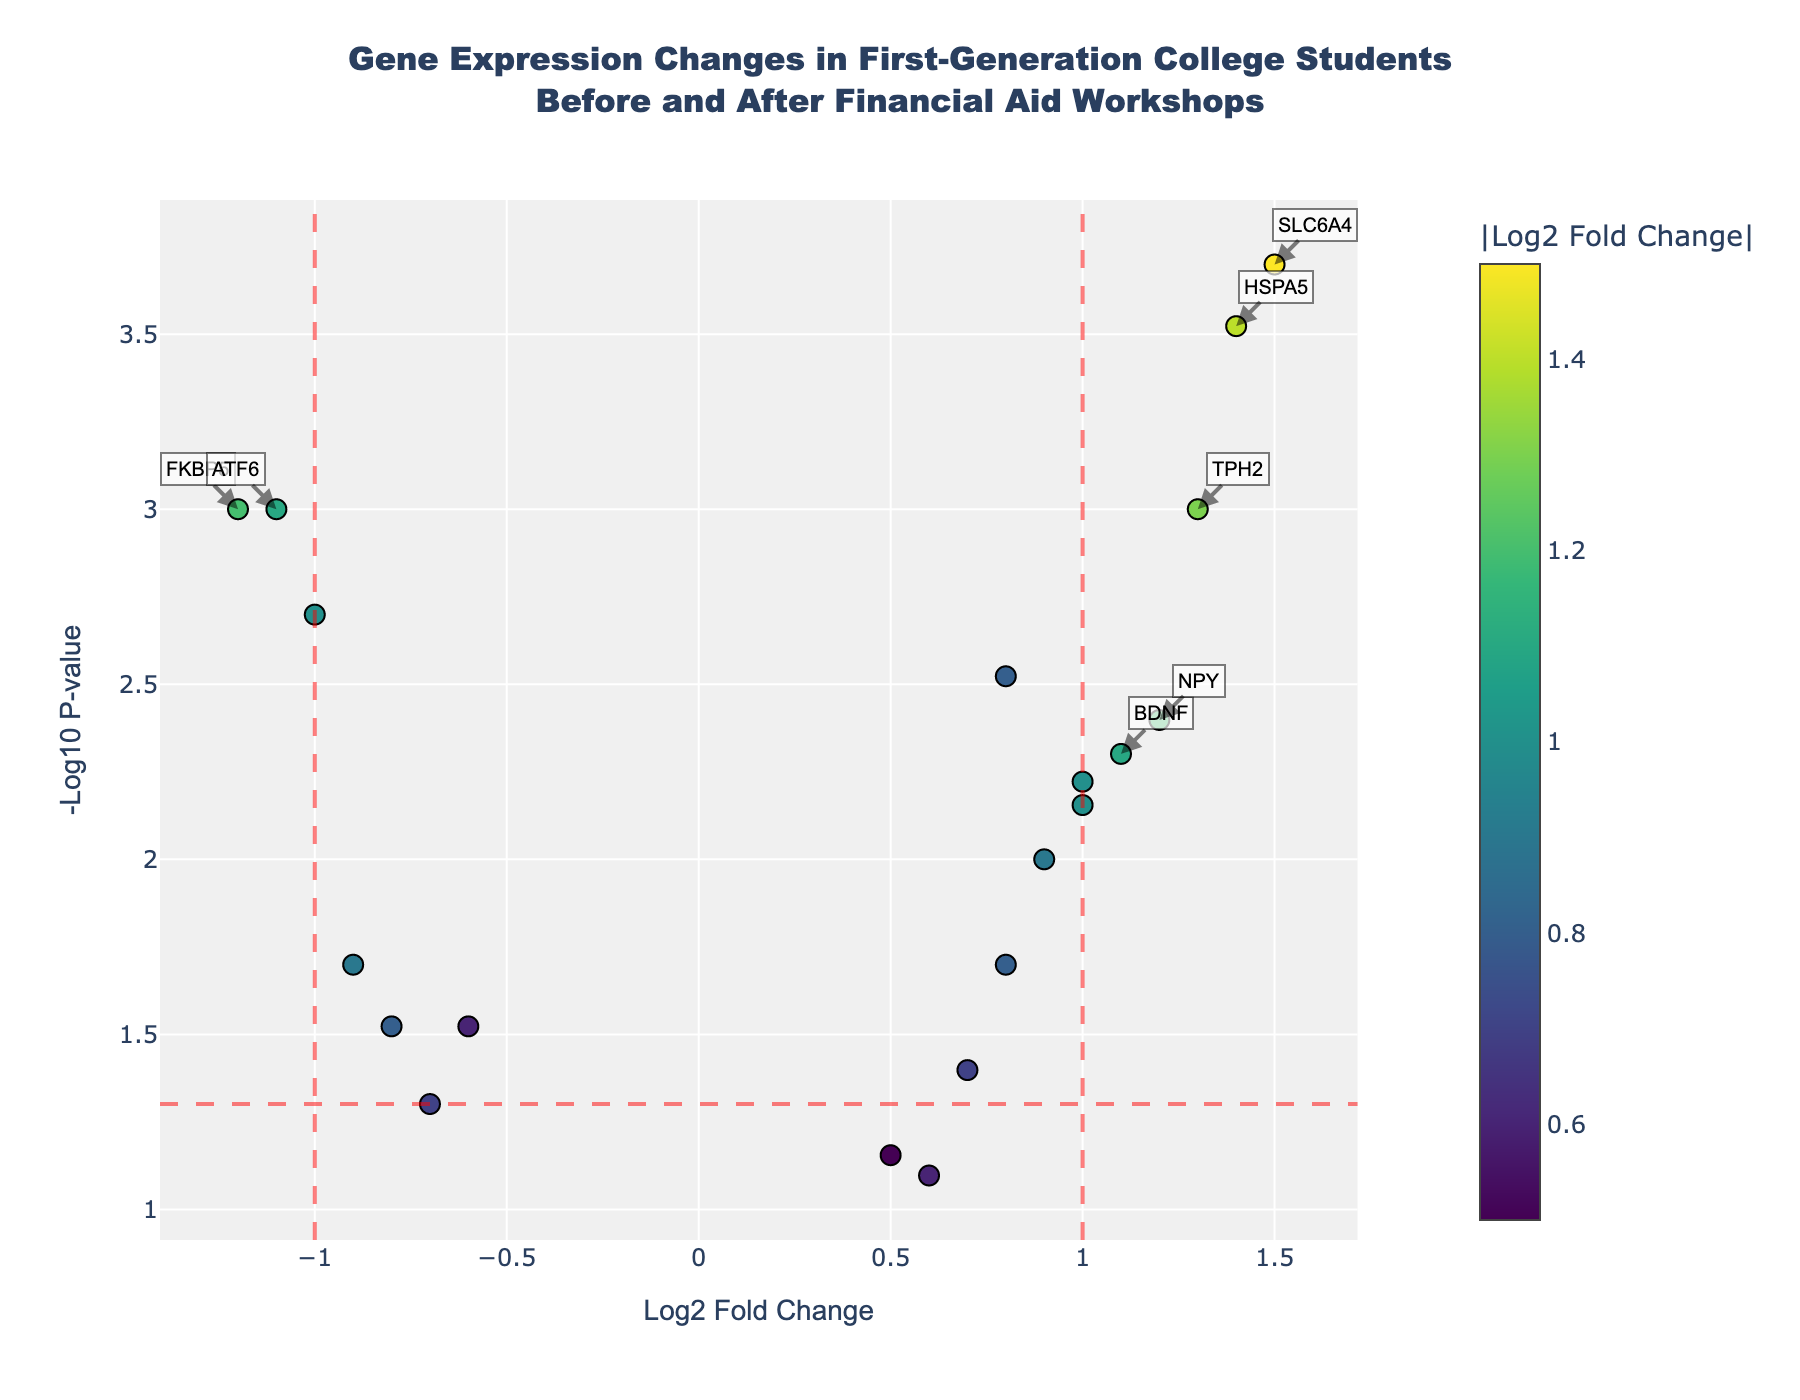What is the title of the plot? The title is textual information displayed at the top of the plot to describe its content. Here it reads 'Gene Expression Changes in First-Generation College Students Before and After Financial Aid Workshops'.
Answer: Gene Expression Changes in First-Generation College Students Before and After Financial Aid Workshops Which axis represents the log2 fold change? The axis title indicates the measure it represents. The x-axis is titled 'Log2 Fold Change', so it shows the log2 fold change.
Answer: x-axis What does the y-axis represent? The y-axis title provides this information. It's labeled '-Log10 P-value', indicating it represents the negative logarithm of the p-value.
Answer: -Log10 P-value How many genes have a log2 fold change greater than 1? We need to count the points to the right of the vertical line at x=1 on the plot. Genes like SLC6A4, TPH2, HSPA5, and NPY fall in this region, so there are 4 genes.
Answer: 4 Which gene shows the highest log2 fold change? By finding the farthest point to the right, we observe the gene SLC6A4 with a log2 fold change of 1.5, making it the highest.
Answer: SLC6A4 Which gene has the most statistically significant p-value? The most significant p-value corresponds to the highest point on the y-axis as it translates to the smallest original p-value. The gene with the highest y-value is SLC6A4.
Answer: SLC6A4 What is the approximate p-value for the gene FKBP5? Locate FKBP5 on the figure and read its position on the y-axis. It translates to a -log10(p-value) of approximately 3, which corresponds to a p-value of 0.001.
Answer: 0.001 Compare the fold changes of BDNF and NR3C1. Which gene shows a greater change? Examine the positions of BDNF and NR3C1 on the x-axis. BDNF's fold change is 1.1, whereas NR3C1's fold change is 0.8. Therefore, BDNF shows a greater fold change.
Answer: BDNF 